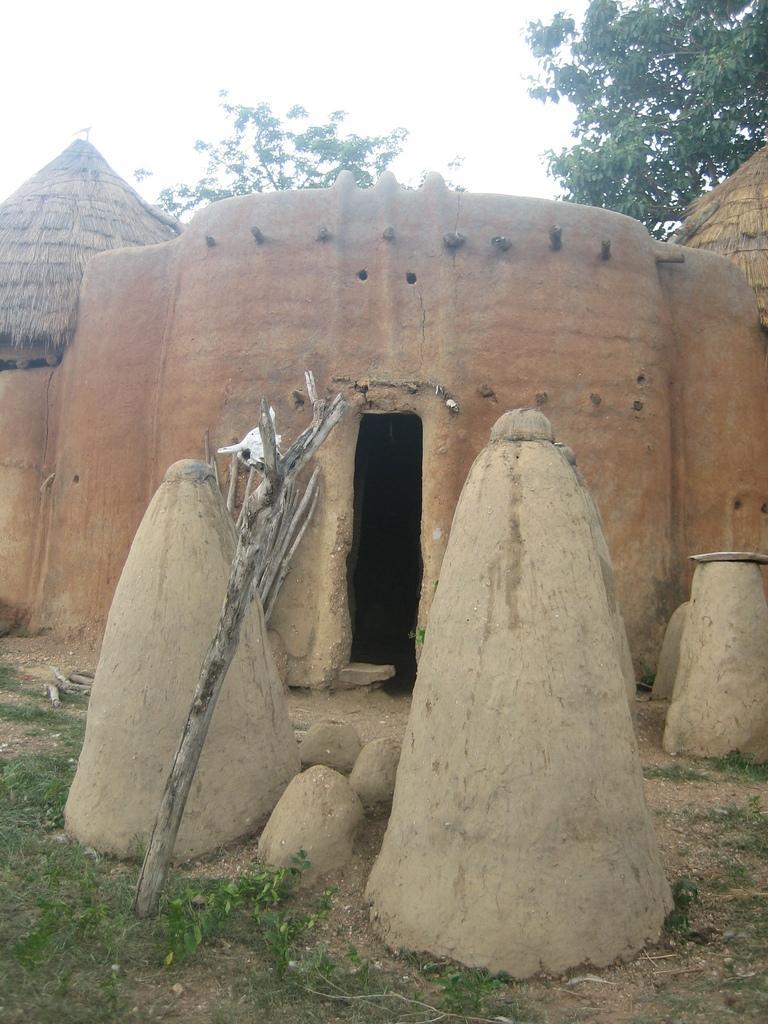Could you give a brief overview of what you see in this image? In this image we can see a house. We can also see some wooden poles, stones, grass, plants, trees and the sky. 